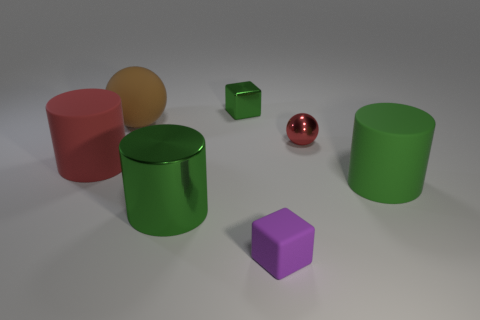What can you infer about the physical properties of the objects based on their appearances? Based on their appearances, the objects likely have different physical properties. The red sphere's shininess suggests it has a smooth surface and may be quite hard, potentially made of metal. The green objects, due to their matte finish, might be made of a lighter and less durable material like plastic. The purple cube, with its solid color and lack of reflection, could be similar to the green objects in terms of material, but without tactile examination, it's difficult to determine the exact properties. The orange sphere's slight reflectivity suggests it might have a slightly harder surface than the green and purple cube but doesn't reveal much about its flexibility or durability. Can you say anything about the weight of these objects based on their appearance? While it's challenging to precisely assess the weight of objects based solely on appearance, we can make educated guesses. The red sphere's reflective surface might indicate that it's made of metal, which typically means it's denser and therefore heavier than the other objects if they are plastic. The green cylinder and cube, along with the purple cube, show no signs of weightiness in their appearance; their matte finish and simplistic shapes are more characteristic of lightweight materials like plastic. The orange sphere's partially reflective surface hints that it might have more weight than the green and purple objects but possibly less than the red sphere. 